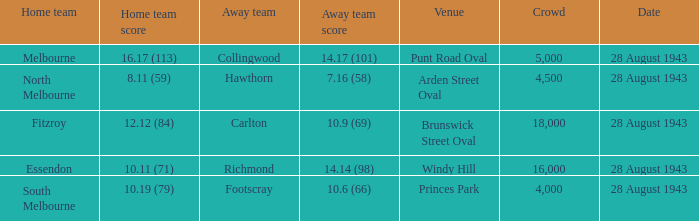Where was the game played with an away team score of 14.17 (101)? Punt Road Oval. I'm looking to parse the entire table for insights. Could you assist me with that? {'header': ['Home team', 'Home team score', 'Away team', 'Away team score', 'Venue', 'Crowd', 'Date'], 'rows': [['Melbourne', '16.17 (113)', 'Collingwood', '14.17 (101)', 'Punt Road Oval', '5,000', '28 August 1943'], ['North Melbourne', '8.11 (59)', 'Hawthorn', '7.16 (58)', 'Arden Street Oval', '4,500', '28 August 1943'], ['Fitzroy', '12.12 (84)', 'Carlton', '10.9 (69)', 'Brunswick Street Oval', '18,000', '28 August 1943'], ['Essendon', '10.11 (71)', 'Richmond', '14.14 (98)', 'Windy Hill', '16,000', '28 August 1943'], ['South Melbourne', '10.19 (79)', 'Footscray', '10.6 (66)', 'Princes Park', '4,000', '28 August 1943']]} 